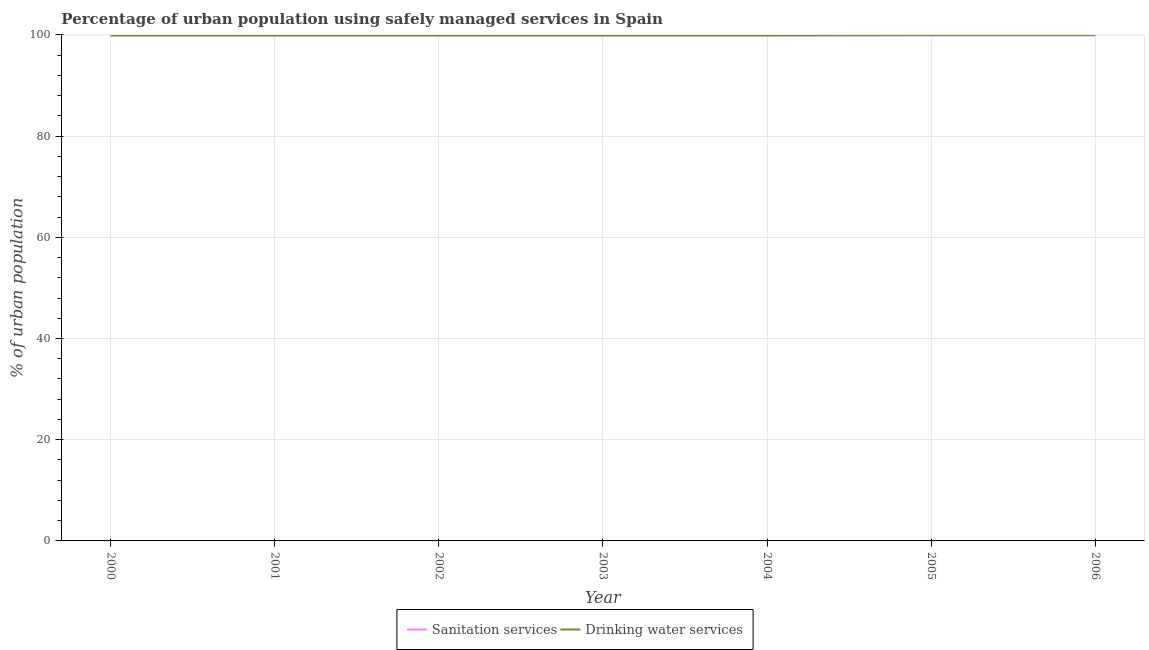Does the line corresponding to percentage of urban population who used drinking water services intersect with the line corresponding to percentage of urban population who used sanitation services?
Make the answer very short. Yes. Is the number of lines equal to the number of legend labels?
Your answer should be very brief. Yes. What is the percentage of urban population who used drinking water services in 2003?
Offer a very short reply. 99.9. Across all years, what is the maximum percentage of urban population who used sanitation services?
Keep it short and to the point. 99.9. Across all years, what is the minimum percentage of urban population who used sanitation services?
Offer a terse response. 99.9. What is the total percentage of urban population who used drinking water services in the graph?
Keep it short and to the point. 699.5. What is the difference between the percentage of urban population who used sanitation services in 2002 and that in 2003?
Your answer should be very brief. 0. What is the difference between the percentage of urban population who used sanitation services in 2003 and the percentage of urban population who used drinking water services in 2006?
Your response must be concise. -0.1. What is the average percentage of urban population who used sanitation services per year?
Your response must be concise. 99.9. In the year 2002, what is the difference between the percentage of urban population who used sanitation services and percentage of urban population who used drinking water services?
Your response must be concise. 0. In how many years, is the percentage of urban population who used drinking water services greater than 92 %?
Give a very brief answer. 7. What is the ratio of the percentage of urban population who used drinking water services in 2002 to that in 2005?
Your answer should be compact. 1. Is the percentage of urban population who used drinking water services in 2004 less than that in 2005?
Your answer should be very brief. Yes. What is the difference between the highest and the second highest percentage of urban population who used drinking water services?
Provide a short and direct response. 0. What is the difference between the highest and the lowest percentage of urban population who used drinking water services?
Offer a very short reply. 0.1. In how many years, is the percentage of urban population who used sanitation services greater than the average percentage of urban population who used sanitation services taken over all years?
Make the answer very short. 7. Is the sum of the percentage of urban population who used drinking water services in 2002 and 2005 greater than the maximum percentage of urban population who used sanitation services across all years?
Your answer should be compact. Yes. Does the percentage of urban population who used sanitation services monotonically increase over the years?
Give a very brief answer. No. How many lines are there?
Your response must be concise. 2. How many years are there in the graph?
Provide a short and direct response. 7. Does the graph contain grids?
Your answer should be compact. Yes. Where does the legend appear in the graph?
Your answer should be compact. Bottom center. How are the legend labels stacked?
Provide a succinct answer. Horizontal. What is the title of the graph?
Provide a succinct answer. Percentage of urban population using safely managed services in Spain. Does "Study and work" appear as one of the legend labels in the graph?
Provide a succinct answer. No. What is the label or title of the Y-axis?
Provide a short and direct response. % of urban population. What is the % of urban population of Sanitation services in 2000?
Keep it short and to the point. 99.9. What is the % of urban population in Drinking water services in 2000?
Your answer should be very brief. 99.9. What is the % of urban population in Sanitation services in 2001?
Your response must be concise. 99.9. What is the % of urban population in Drinking water services in 2001?
Provide a short and direct response. 99.9. What is the % of urban population in Sanitation services in 2002?
Offer a very short reply. 99.9. What is the % of urban population of Drinking water services in 2002?
Your answer should be compact. 99.9. What is the % of urban population in Sanitation services in 2003?
Provide a succinct answer. 99.9. What is the % of urban population in Drinking water services in 2003?
Offer a terse response. 99.9. What is the % of urban population in Sanitation services in 2004?
Your answer should be compact. 99.9. What is the % of urban population of Drinking water services in 2004?
Provide a succinct answer. 99.9. What is the % of urban population in Sanitation services in 2005?
Your answer should be very brief. 99.9. What is the % of urban population in Sanitation services in 2006?
Offer a terse response. 99.9. Across all years, what is the maximum % of urban population in Sanitation services?
Provide a short and direct response. 99.9. Across all years, what is the maximum % of urban population of Drinking water services?
Provide a succinct answer. 100. Across all years, what is the minimum % of urban population in Sanitation services?
Provide a short and direct response. 99.9. Across all years, what is the minimum % of urban population in Drinking water services?
Your response must be concise. 99.9. What is the total % of urban population in Sanitation services in the graph?
Keep it short and to the point. 699.3. What is the total % of urban population of Drinking water services in the graph?
Your response must be concise. 699.5. What is the difference between the % of urban population in Sanitation services in 2000 and that in 2002?
Provide a short and direct response. 0. What is the difference between the % of urban population of Drinking water services in 2000 and that in 2002?
Provide a succinct answer. 0. What is the difference between the % of urban population in Sanitation services in 2000 and that in 2003?
Provide a short and direct response. 0. What is the difference between the % of urban population of Sanitation services in 2000 and that in 2004?
Keep it short and to the point. 0. What is the difference between the % of urban population of Sanitation services in 2000 and that in 2005?
Give a very brief answer. 0. What is the difference between the % of urban population of Sanitation services in 2001 and that in 2002?
Offer a terse response. 0. What is the difference between the % of urban population in Drinking water services in 2001 and that in 2002?
Your answer should be very brief. 0. What is the difference between the % of urban population in Drinking water services in 2001 and that in 2003?
Offer a very short reply. 0. What is the difference between the % of urban population of Drinking water services in 2001 and that in 2004?
Offer a terse response. 0. What is the difference between the % of urban population of Sanitation services in 2001 and that in 2005?
Your answer should be compact. 0. What is the difference between the % of urban population in Sanitation services in 2001 and that in 2006?
Offer a terse response. 0. What is the difference between the % of urban population of Drinking water services in 2001 and that in 2006?
Ensure brevity in your answer.  -0.1. What is the difference between the % of urban population of Drinking water services in 2002 and that in 2003?
Keep it short and to the point. 0. What is the difference between the % of urban population of Drinking water services in 2002 and that in 2006?
Offer a terse response. -0.1. What is the difference between the % of urban population of Drinking water services in 2003 and that in 2006?
Your response must be concise. -0.1. What is the difference between the % of urban population of Sanitation services in 2004 and that in 2006?
Offer a very short reply. 0. What is the difference between the % of urban population of Drinking water services in 2004 and that in 2006?
Offer a terse response. -0.1. What is the difference between the % of urban population in Drinking water services in 2005 and that in 2006?
Give a very brief answer. 0. What is the difference between the % of urban population in Sanitation services in 2000 and the % of urban population in Drinking water services in 2002?
Provide a succinct answer. 0. What is the difference between the % of urban population of Sanitation services in 2000 and the % of urban population of Drinking water services in 2003?
Provide a succinct answer. 0. What is the difference between the % of urban population of Sanitation services in 2000 and the % of urban population of Drinking water services in 2006?
Make the answer very short. -0.1. What is the difference between the % of urban population in Sanitation services in 2001 and the % of urban population in Drinking water services in 2002?
Provide a short and direct response. 0. What is the difference between the % of urban population of Sanitation services in 2001 and the % of urban population of Drinking water services in 2004?
Make the answer very short. 0. What is the difference between the % of urban population in Sanitation services in 2001 and the % of urban population in Drinking water services in 2006?
Provide a succinct answer. -0.1. What is the difference between the % of urban population of Sanitation services in 2002 and the % of urban population of Drinking water services in 2006?
Give a very brief answer. -0.1. What is the difference between the % of urban population of Sanitation services in 2003 and the % of urban population of Drinking water services in 2005?
Your answer should be compact. -0.1. What is the difference between the % of urban population of Sanitation services in 2004 and the % of urban population of Drinking water services in 2006?
Make the answer very short. -0.1. What is the difference between the % of urban population in Sanitation services in 2005 and the % of urban population in Drinking water services in 2006?
Provide a short and direct response. -0.1. What is the average % of urban population in Sanitation services per year?
Make the answer very short. 99.9. What is the average % of urban population of Drinking water services per year?
Make the answer very short. 99.93. In the year 2001, what is the difference between the % of urban population of Sanitation services and % of urban population of Drinking water services?
Provide a short and direct response. 0. In the year 2002, what is the difference between the % of urban population in Sanitation services and % of urban population in Drinking water services?
Your response must be concise. 0. In the year 2003, what is the difference between the % of urban population in Sanitation services and % of urban population in Drinking water services?
Your answer should be very brief. 0. In the year 2005, what is the difference between the % of urban population in Sanitation services and % of urban population in Drinking water services?
Your answer should be very brief. -0.1. What is the ratio of the % of urban population in Drinking water services in 2000 to that in 2001?
Ensure brevity in your answer.  1. What is the ratio of the % of urban population of Sanitation services in 2000 to that in 2002?
Provide a short and direct response. 1. What is the ratio of the % of urban population of Drinking water services in 2000 to that in 2002?
Keep it short and to the point. 1. What is the ratio of the % of urban population of Sanitation services in 2001 to that in 2002?
Make the answer very short. 1. What is the ratio of the % of urban population in Sanitation services in 2001 to that in 2003?
Keep it short and to the point. 1. What is the ratio of the % of urban population in Drinking water services in 2001 to that in 2003?
Your answer should be compact. 1. What is the ratio of the % of urban population in Drinking water services in 2001 to that in 2004?
Keep it short and to the point. 1. What is the ratio of the % of urban population in Sanitation services in 2001 to that in 2005?
Ensure brevity in your answer.  1. What is the ratio of the % of urban population in Drinking water services in 2001 to that in 2005?
Your answer should be compact. 1. What is the ratio of the % of urban population in Drinking water services in 2001 to that in 2006?
Offer a very short reply. 1. What is the ratio of the % of urban population in Sanitation services in 2002 to that in 2003?
Provide a succinct answer. 1. What is the ratio of the % of urban population of Drinking water services in 2002 to that in 2003?
Give a very brief answer. 1. What is the ratio of the % of urban population of Sanitation services in 2002 to that in 2004?
Provide a succinct answer. 1. What is the ratio of the % of urban population of Drinking water services in 2002 to that in 2005?
Your answer should be compact. 1. What is the ratio of the % of urban population of Sanitation services in 2002 to that in 2006?
Provide a succinct answer. 1. What is the ratio of the % of urban population of Sanitation services in 2003 to that in 2004?
Ensure brevity in your answer.  1. What is the ratio of the % of urban population of Drinking water services in 2003 to that in 2006?
Ensure brevity in your answer.  1. What is the ratio of the % of urban population in Drinking water services in 2004 to that in 2006?
Your answer should be compact. 1. What is the ratio of the % of urban population in Sanitation services in 2005 to that in 2006?
Provide a succinct answer. 1. What is the ratio of the % of urban population in Drinking water services in 2005 to that in 2006?
Ensure brevity in your answer.  1. What is the difference between the highest and the second highest % of urban population in Drinking water services?
Offer a terse response. 0. What is the difference between the highest and the lowest % of urban population of Drinking water services?
Offer a terse response. 0.1. 